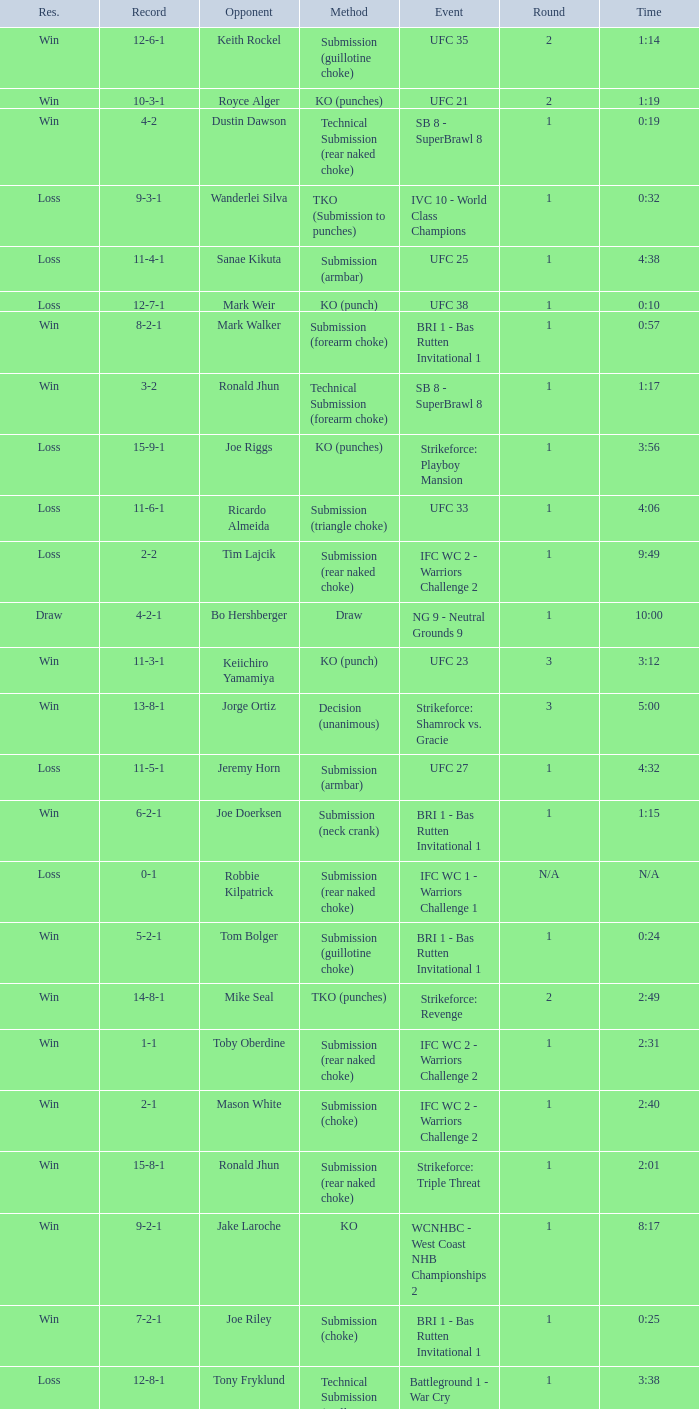What is the record when the fight was against keith rockel? 12-6-1. Would you be able to parse every entry in this table? {'header': ['Res.', 'Record', 'Opponent', 'Method', 'Event', 'Round', 'Time'], 'rows': [['Win', '12-6-1', 'Keith Rockel', 'Submission (guillotine choke)', 'UFC 35', '2', '1:14'], ['Win', '10-3-1', 'Royce Alger', 'KO (punches)', 'UFC 21', '2', '1:19'], ['Win', '4-2', 'Dustin Dawson', 'Technical Submission (rear naked choke)', 'SB 8 - SuperBrawl 8', '1', '0:19'], ['Loss', '9-3-1', 'Wanderlei Silva', 'TKO (Submission to punches)', 'IVC 10 - World Class Champions', '1', '0:32'], ['Loss', '11-4-1', 'Sanae Kikuta', 'Submission (armbar)', 'UFC 25', '1', '4:38'], ['Loss', '12-7-1', 'Mark Weir', 'KO (punch)', 'UFC 38', '1', '0:10'], ['Win', '8-2-1', 'Mark Walker', 'Submission (forearm choke)', 'BRI 1 - Bas Rutten Invitational 1', '1', '0:57'], ['Win', '3-2', 'Ronald Jhun', 'Technical Submission (forearm choke)', 'SB 8 - SuperBrawl 8', '1', '1:17'], ['Loss', '15-9-1', 'Joe Riggs', 'KO (punches)', 'Strikeforce: Playboy Mansion', '1', '3:56'], ['Loss', '11-6-1', 'Ricardo Almeida', 'Submission (triangle choke)', 'UFC 33', '1', '4:06'], ['Loss', '2-2', 'Tim Lajcik', 'Submission (rear naked choke)', 'IFC WC 2 - Warriors Challenge 2', '1', '9:49'], ['Draw', '4-2-1', 'Bo Hershberger', 'Draw', 'NG 9 - Neutral Grounds 9', '1', '10:00'], ['Win', '11-3-1', 'Keiichiro Yamamiya', 'KO (punch)', 'UFC 23', '3', '3:12'], ['Win', '13-8-1', 'Jorge Ortiz', 'Decision (unanimous)', 'Strikeforce: Shamrock vs. Gracie', '3', '5:00'], ['Loss', '11-5-1', 'Jeremy Horn', 'Submission (armbar)', 'UFC 27', '1', '4:32'], ['Win', '6-2-1', 'Joe Doerksen', 'Submission (neck crank)', 'BRI 1 - Bas Rutten Invitational 1', '1', '1:15'], ['Loss', '0-1', 'Robbie Kilpatrick', 'Submission (rear naked choke)', 'IFC WC 1 - Warriors Challenge 1', 'N/A', 'N/A'], ['Win', '5-2-1', 'Tom Bolger', 'Submission (guillotine choke)', 'BRI 1 - Bas Rutten Invitational 1', '1', '0:24'], ['Win', '14-8-1', 'Mike Seal', 'TKO (punches)', 'Strikeforce: Revenge', '2', '2:49'], ['Win', '1-1', 'Toby Oberdine', 'Submission (rear naked choke)', 'IFC WC 2 - Warriors Challenge 2', '1', '2:31'], ['Win', '2-1', 'Mason White', 'Submission (choke)', 'IFC WC 2 - Warriors Challenge 2', '1', '2:40'], ['Win', '15-8-1', 'Ronald Jhun', 'Submission (rear naked choke)', 'Strikeforce: Triple Threat', '1', '2:01'], ['Win', '9-2-1', 'Jake Laroche', 'KO', 'WCNHBC - West Coast NHB Championships 2', '1', '8:17'], ['Win', '7-2-1', 'Joe Riley', 'Submission (choke)', 'BRI 1 - Bas Rutten Invitational 1', '1', '0:25'], ['Loss', '12-8-1', 'Tony Fryklund', 'Technical Submission (guillotine choke)', 'Battleground 1 - War Cry', '1', '3:38']]} 